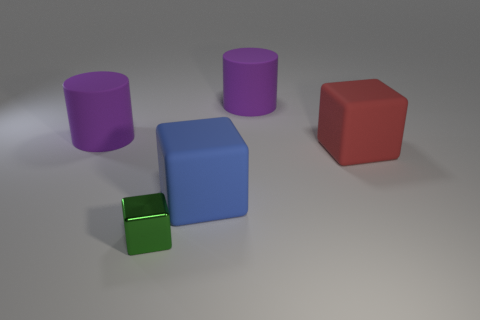Are there any other things that are made of the same material as the green block?
Provide a short and direct response. No. Do the purple object that is left of the metallic cube and the matte object in front of the large red matte block have the same size?
Your answer should be compact. Yes. What shape is the purple matte object that is behind the big rubber thing left of the large object that is in front of the big red rubber thing?
Your answer should be compact. Cylinder. The other metal thing that is the same shape as the big blue thing is what size?
Your answer should be compact. Small. There is a object that is on the left side of the blue rubber cube and behind the tiny object; what is its color?
Offer a very short reply. Purple. Does the tiny cube have the same material as the large purple cylinder that is left of the blue thing?
Ensure brevity in your answer.  No. Is the number of small green metal things that are in front of the tiny object less than the number of big matte blocks?
Offer a very short reply. Yes. How many other things are there of the same shape as the tiny metallic thing?
Keep it short and to the point. 2. Is there any other thing of the same color as the shiny object?
Your response must be concise. No. There is a tiny object; does it have the same color as the rubber cylinder to the left of the metal block?
Offer a very short reply. No. 